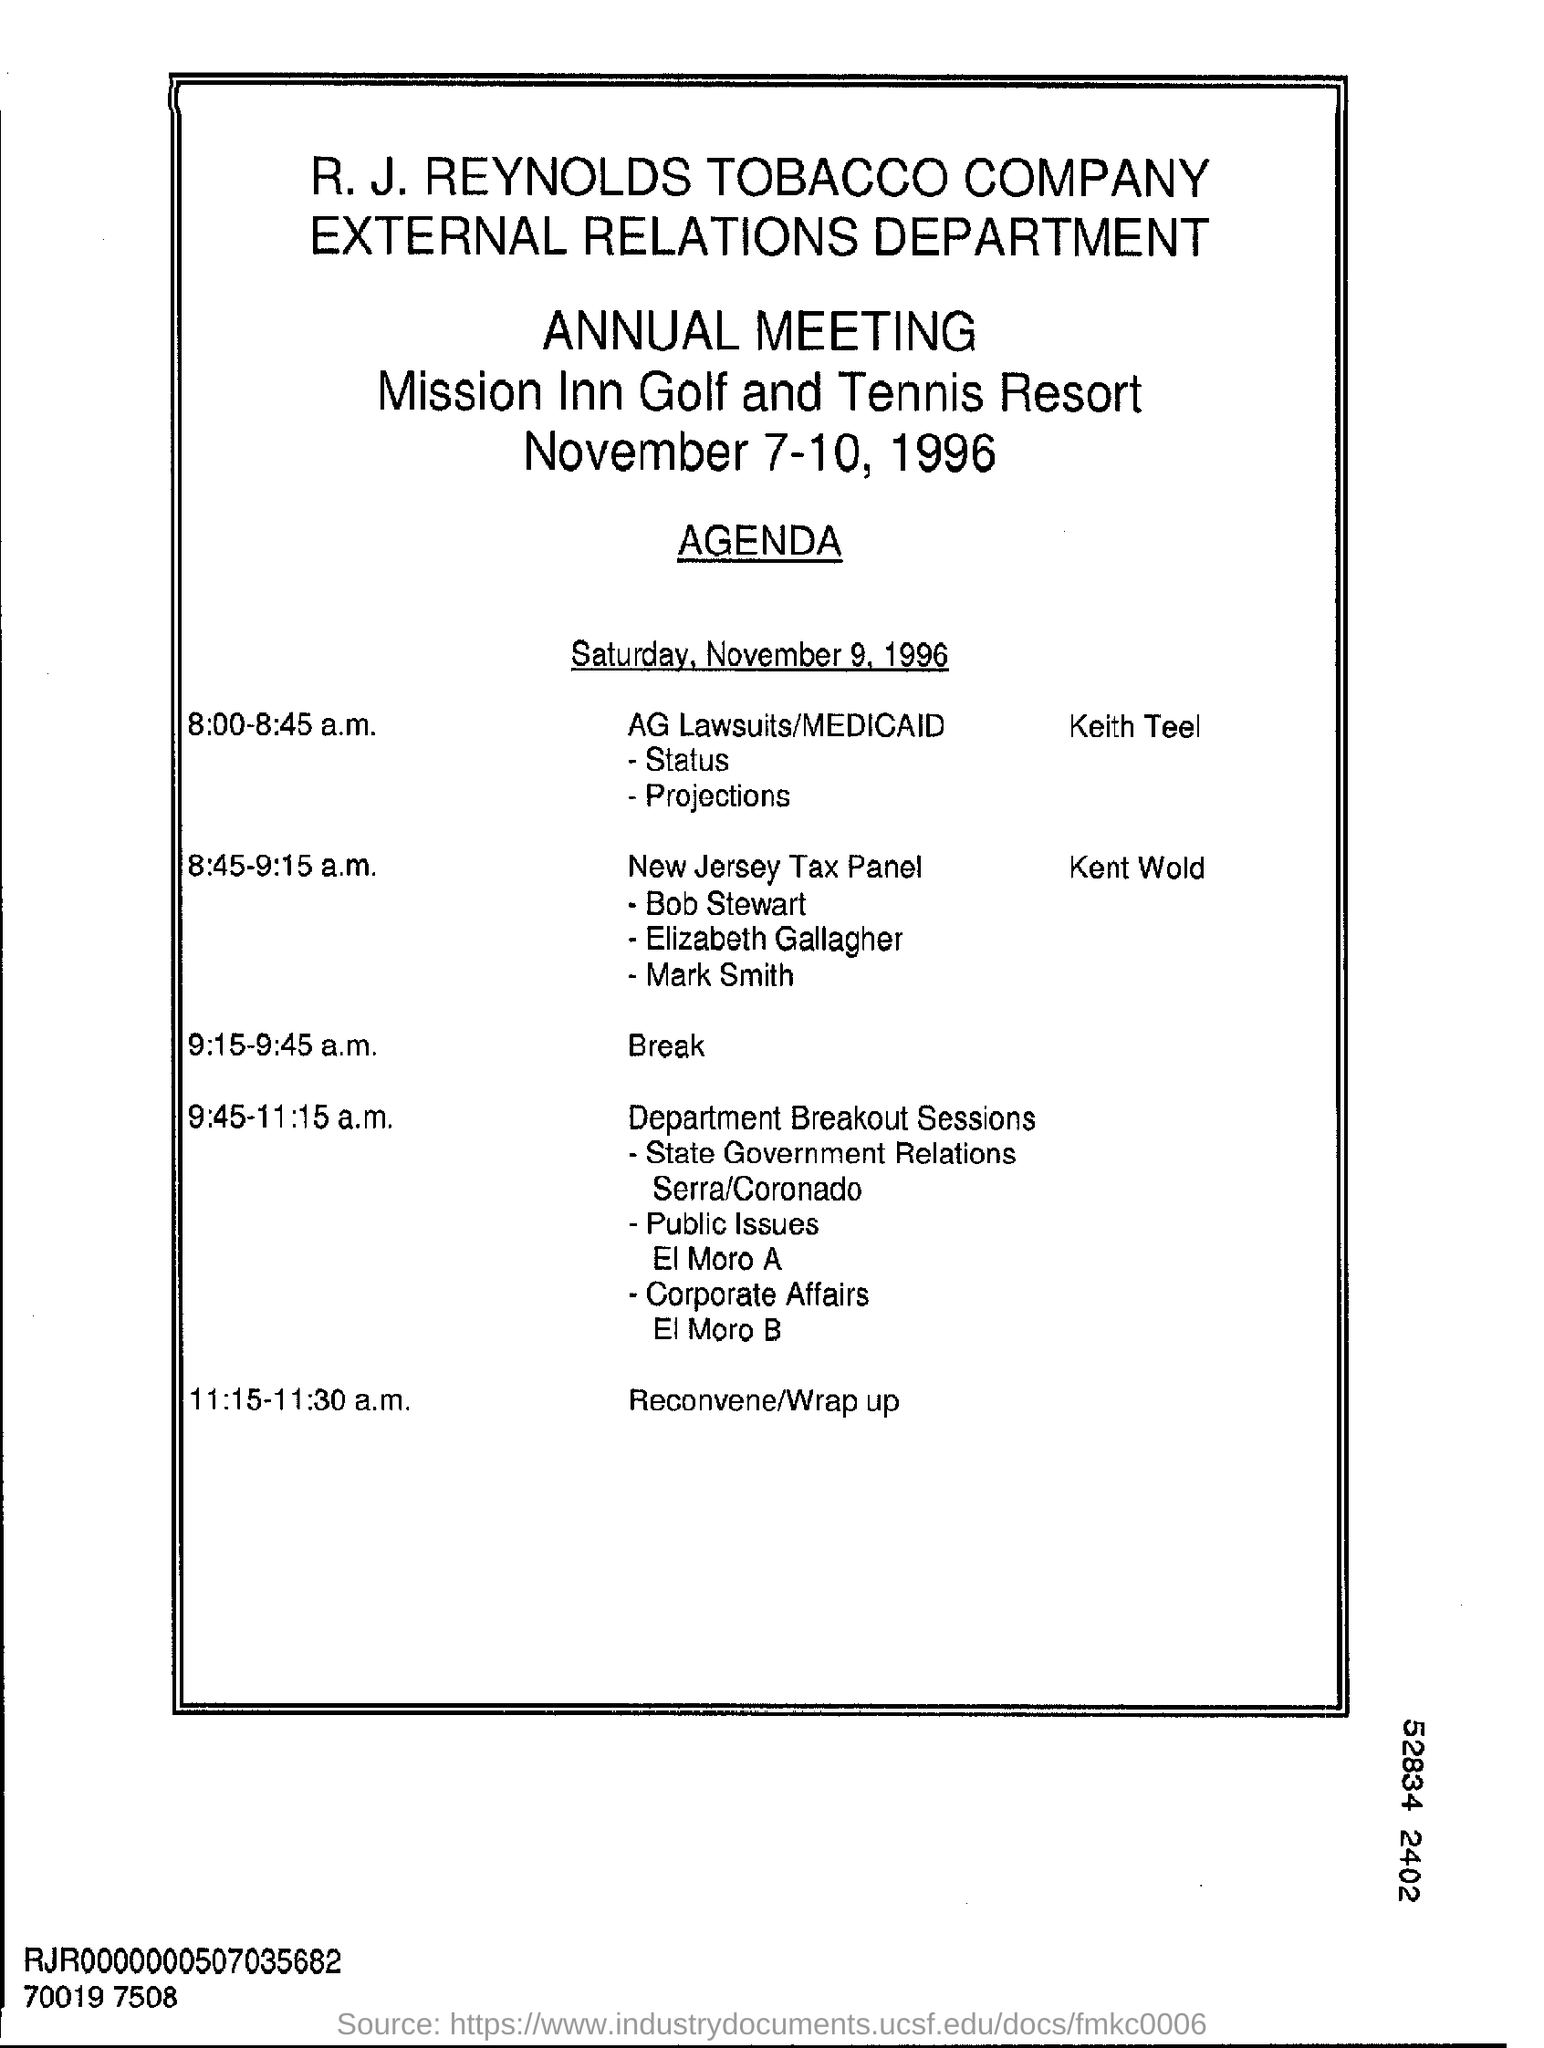Identify some key points in this picture. The time scheduled for the break is from 9:15 to 9:45 a.m. R.J. Reynolds tobacco company is the name of a tobacco company. 